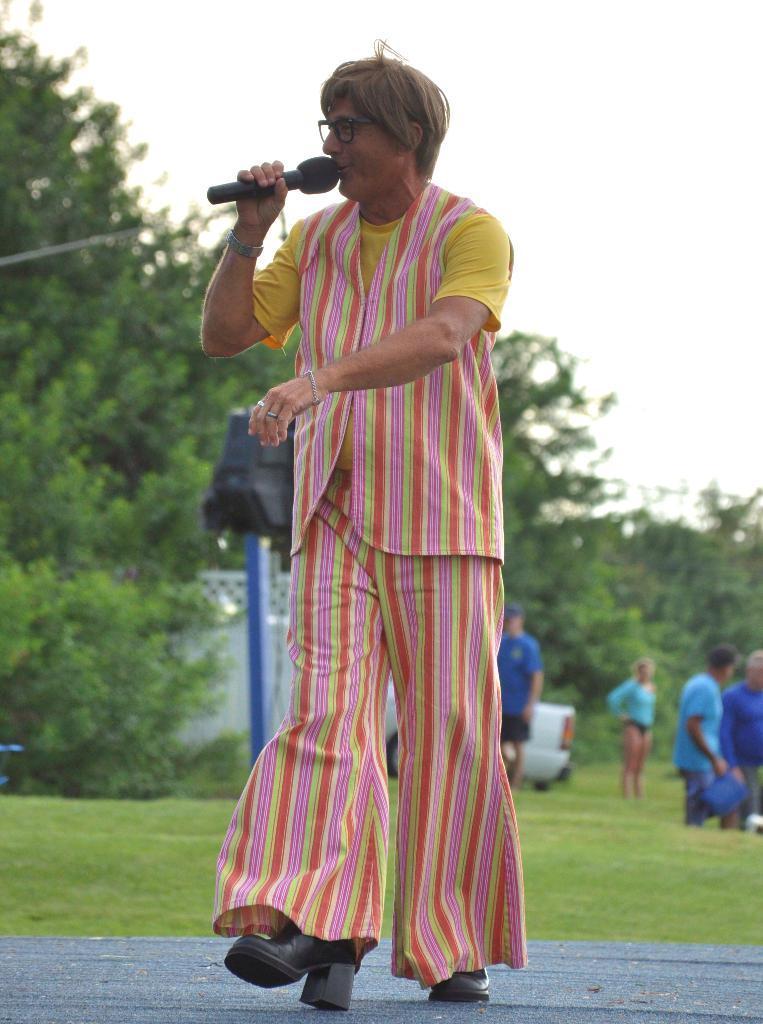How would you summarize this image in a sentence or two? In this image in the foreground there is one person who is holding a mike and talking, and in the background there are some persons, wall and some object and trees. At the bottom there is walkway and grass. 